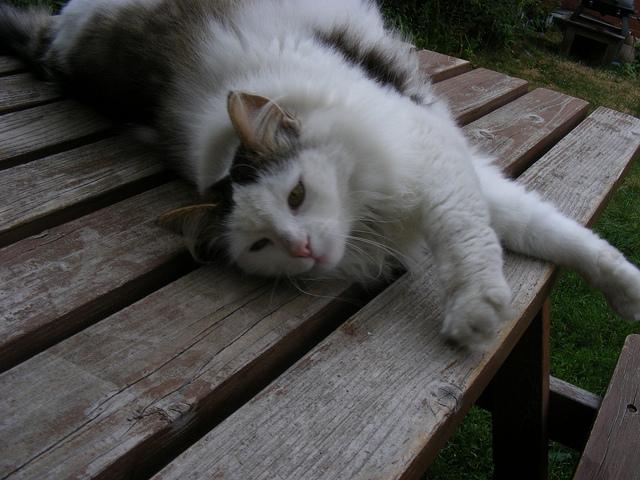What is laying in front of the cat?
Give a very brief answer. Nothing. What is the cat doing?
Keep it brief. Stretching. Is the cat trying to play with the camera?
Answer briefly. No. Is the cat outside?
Short answer required. Yes. Is the cat laying near a laptop and other electronics?
Concise answer only. No. 